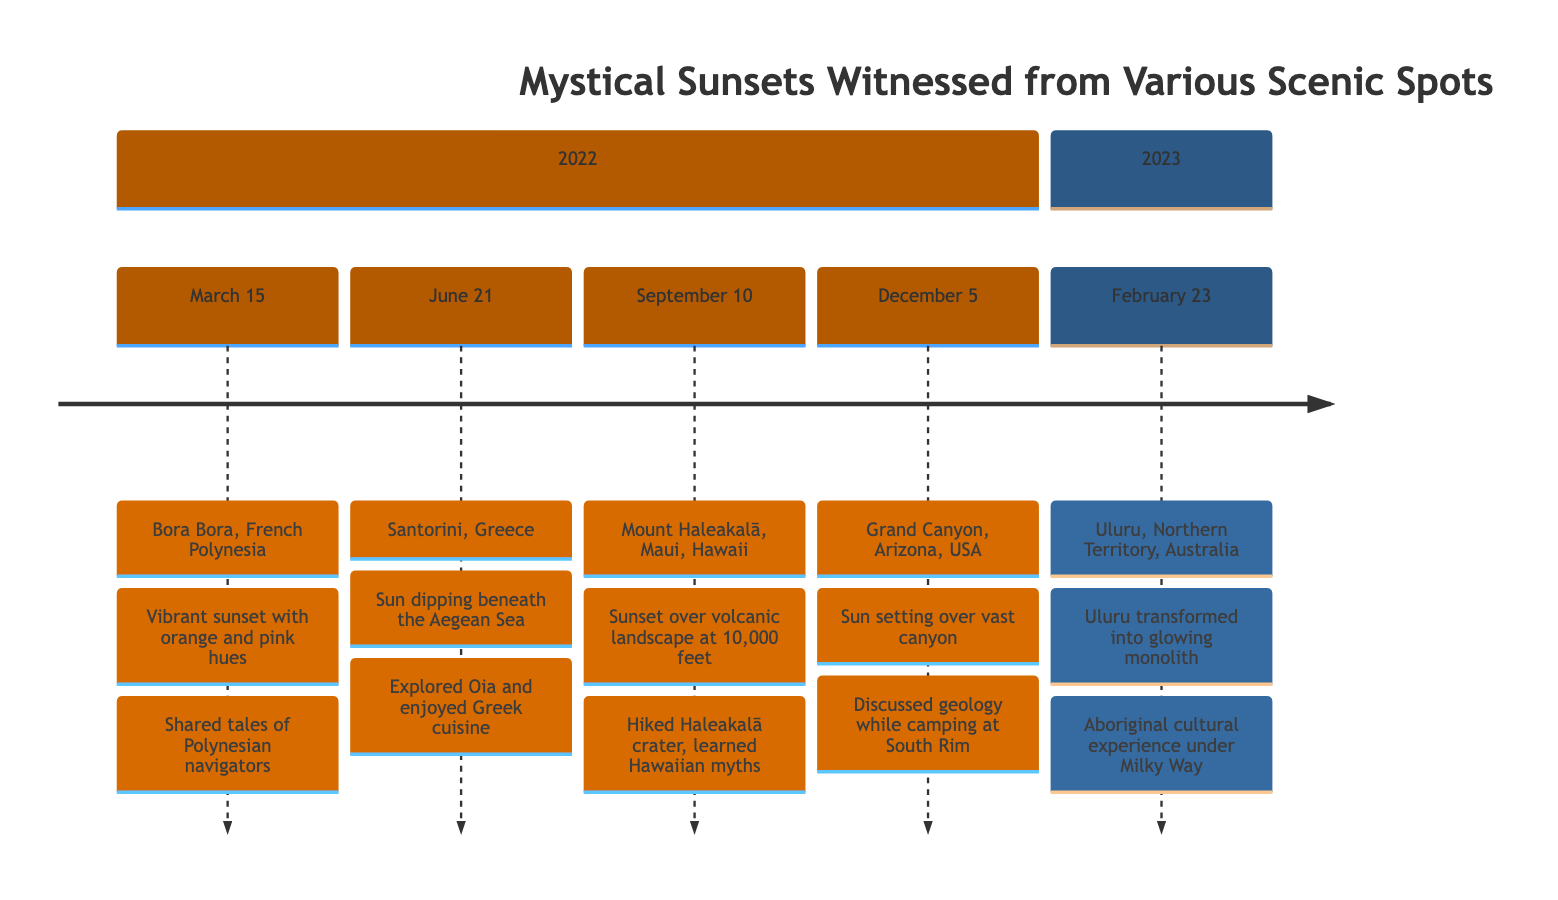What date was the sunset witnessed in Bora Bora? The diagram indicates that the sunset in Bora Bora, French Polynesia, occurred on March 15, 2022.
Answer: March 15, 2022 Which location features a sunset that turns cliffs into shades of red and purple? The Grand Canyon in Arizona, USA is noted in the diagram for its sunset that turns the cliffs into shades of red and purple on December 5, 2022.
Answer: Grand Canyon How many sunsets were witnessed in the year 2022? By counting the entries under the year 2022 in the timeline, we find there are four distinct sunsets documented.
Answer: 4 What experience was shared while watching the sunset at Uluru? Referring to the Uluru entry, the diagram mentions attending an Aboriginal cultural experience and sharing stories under the Milky Way as the experience.
Answer: Aboriginal cultural experience Which sunset was observed while hiking through a crater? The sunset at Mount Haleakalā in Maui, Hawaii, is described in the timeline as being observed while hiking through the Haleakalā crater on September 10, 2022.
Answer: Mount Haleakalā What color hues were observed during the sunset in Santorini? Looking at the Santorini entry, the sunset is described as bathing the buildings in golden light, which denotes the golden hue.
Answer: Golden light Between which two locations were sunsets witnessed just under three months apart? The sunset in Bora Bora on March 15, 2022, and the sunset in Santorini on June 21, 2022, are under three months apart, specifically by 98 days.
Answer: Bora Bora and Santorini What was a shared activity during the sunset at the Grand Canyon? The diagram states that while camping at the South Rim of the Grand Canyon, there was a discussion about the geological history, indicating this was a shared activity.
Answer: Discussed geology How many scenic spots are featured in total for the mystical sunsets timeline? By going through each entry in the timeline, we see that there are a total of five scenic spots noted in this timeline for sunset observations.
Answer: 5 